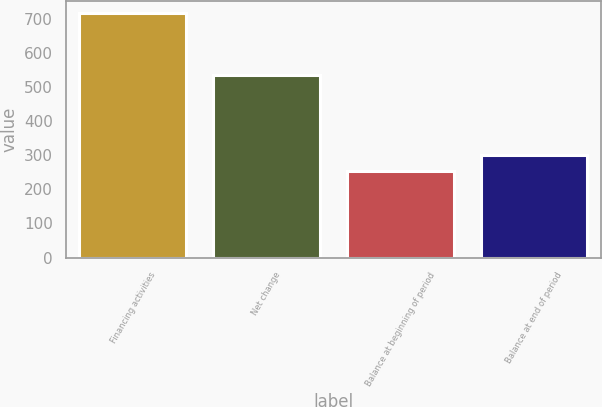Convert chart to OTSL. <chart><loc_0><loc_0><loc_500><loc_500><bar_chart><fcel>Financing activities<fcel>Net change<fcel>Balance at beginning of period<fcel>Balance at end of period<nl><fcel>717<fcel>534<fcel>254<fcel>300.3<nl></chart> 